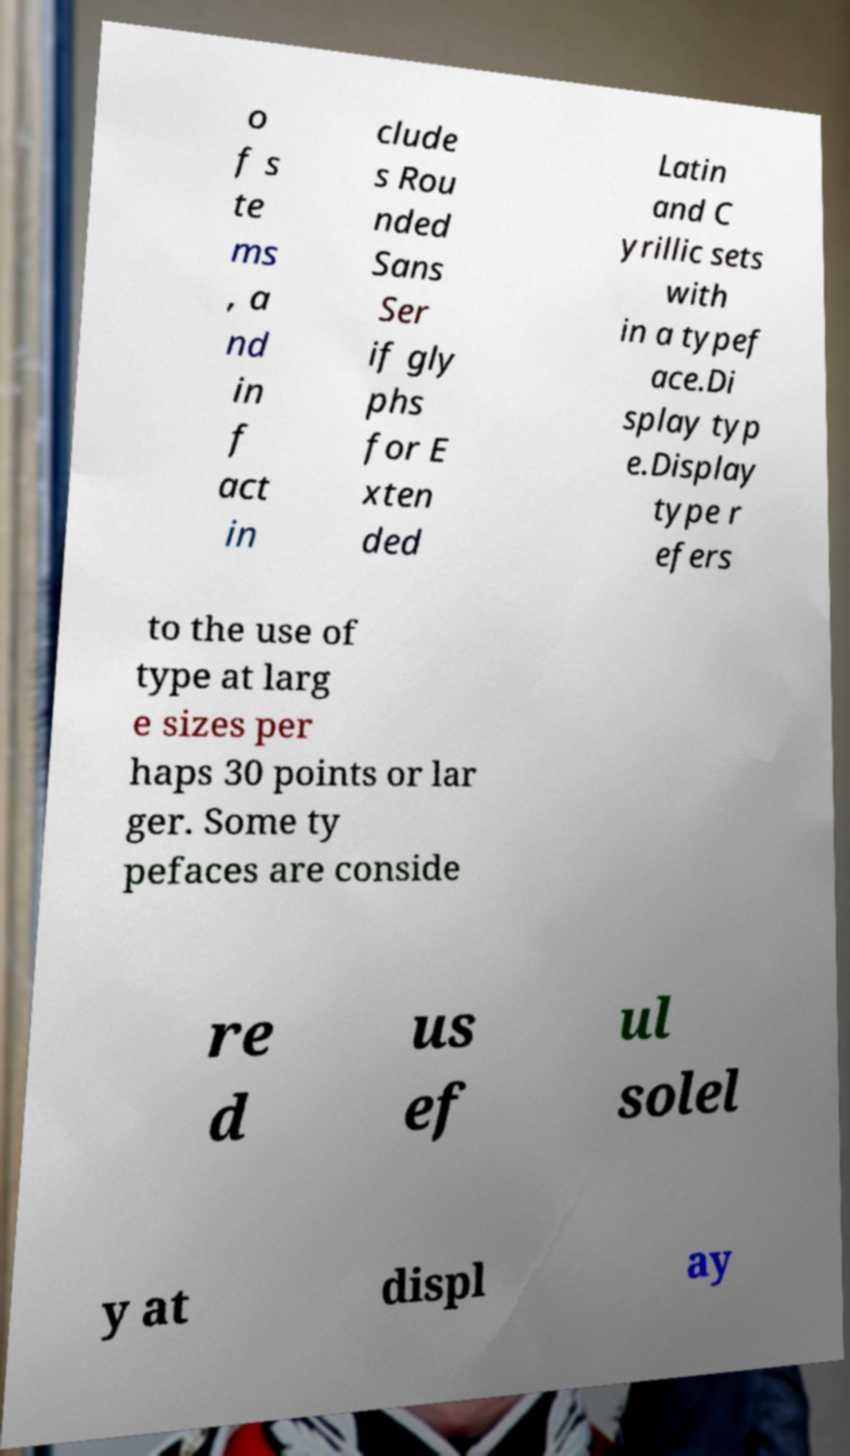Can you read and provide the text displayed in the image?This photo seems to have some interesting text. Can you extract and type it out for me? o f s te ms , a nd in f act in clude s Rou nded Sans Ser if gly phs for E xten ded Latin and C yrillic sets with in a typef ace.Di splay typ e.Display type r efers to the use of type at larg e sizes per haps 30 points or lar ger. Some ty pefaces are conside re d us ef ul solel y at displ ay 